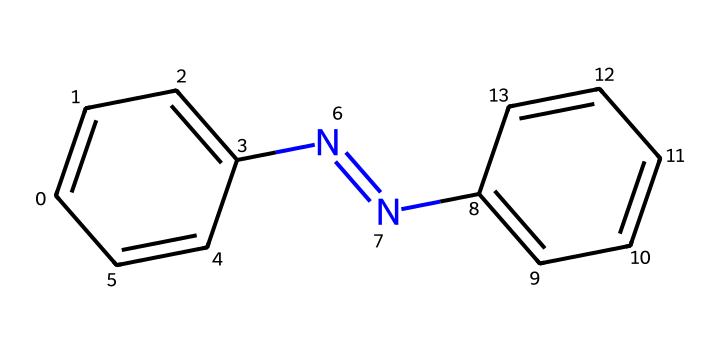What is the molecular formula of azobenzene? The compound has two benzene rings connected by a nitrogen-nitrogen double bond, which gives it a molecular formula of C12H10N2.
Answer: C12H10N2 How many double bonds are in the azobenzene structure? There is one nitrogen-nitrogen double bond and four carbon-carbon double bonds in the two aromatic rings, totaling five double bonds.
Answer: 5 What type of isomerism is exhibited by azobenzene derivatives? The azobenzene derivatives exhibit geometric isomerism due to the restricted rotation around the nitrogen-nitrogen double bond.
Answer: geometric isomerism Which isomer has the bulky groups on opposite sides of the nitrogen-nitrogen bond? The E isomer has the bulky groups (substituents) on opposite sides of the nitrogen-nitrogen bond, resulting in a trans configuration.
Answer: E Which part of the structure determines its photo-responsive properties? The nitrogen-nitrogen double bond is responsible for the photo-responsive properties, as it can isomerize between the E and Z forms upon exposure to light.
Answer: nitrogen-nitrogen double bond How many aromatic rings are present in the azobenzene structure? There are two aromatic rings in the azobenzene structure, each represented by a phenyl group.
Answer: 2 What is the effect of substituents on the azobenzene derivatives? Substituents can influence the stability, absorption wavelengths, and rate of isomerization of the azobenzene derivatives, affecting their application in responsive materials.
Answer: influence stability and isomerization 